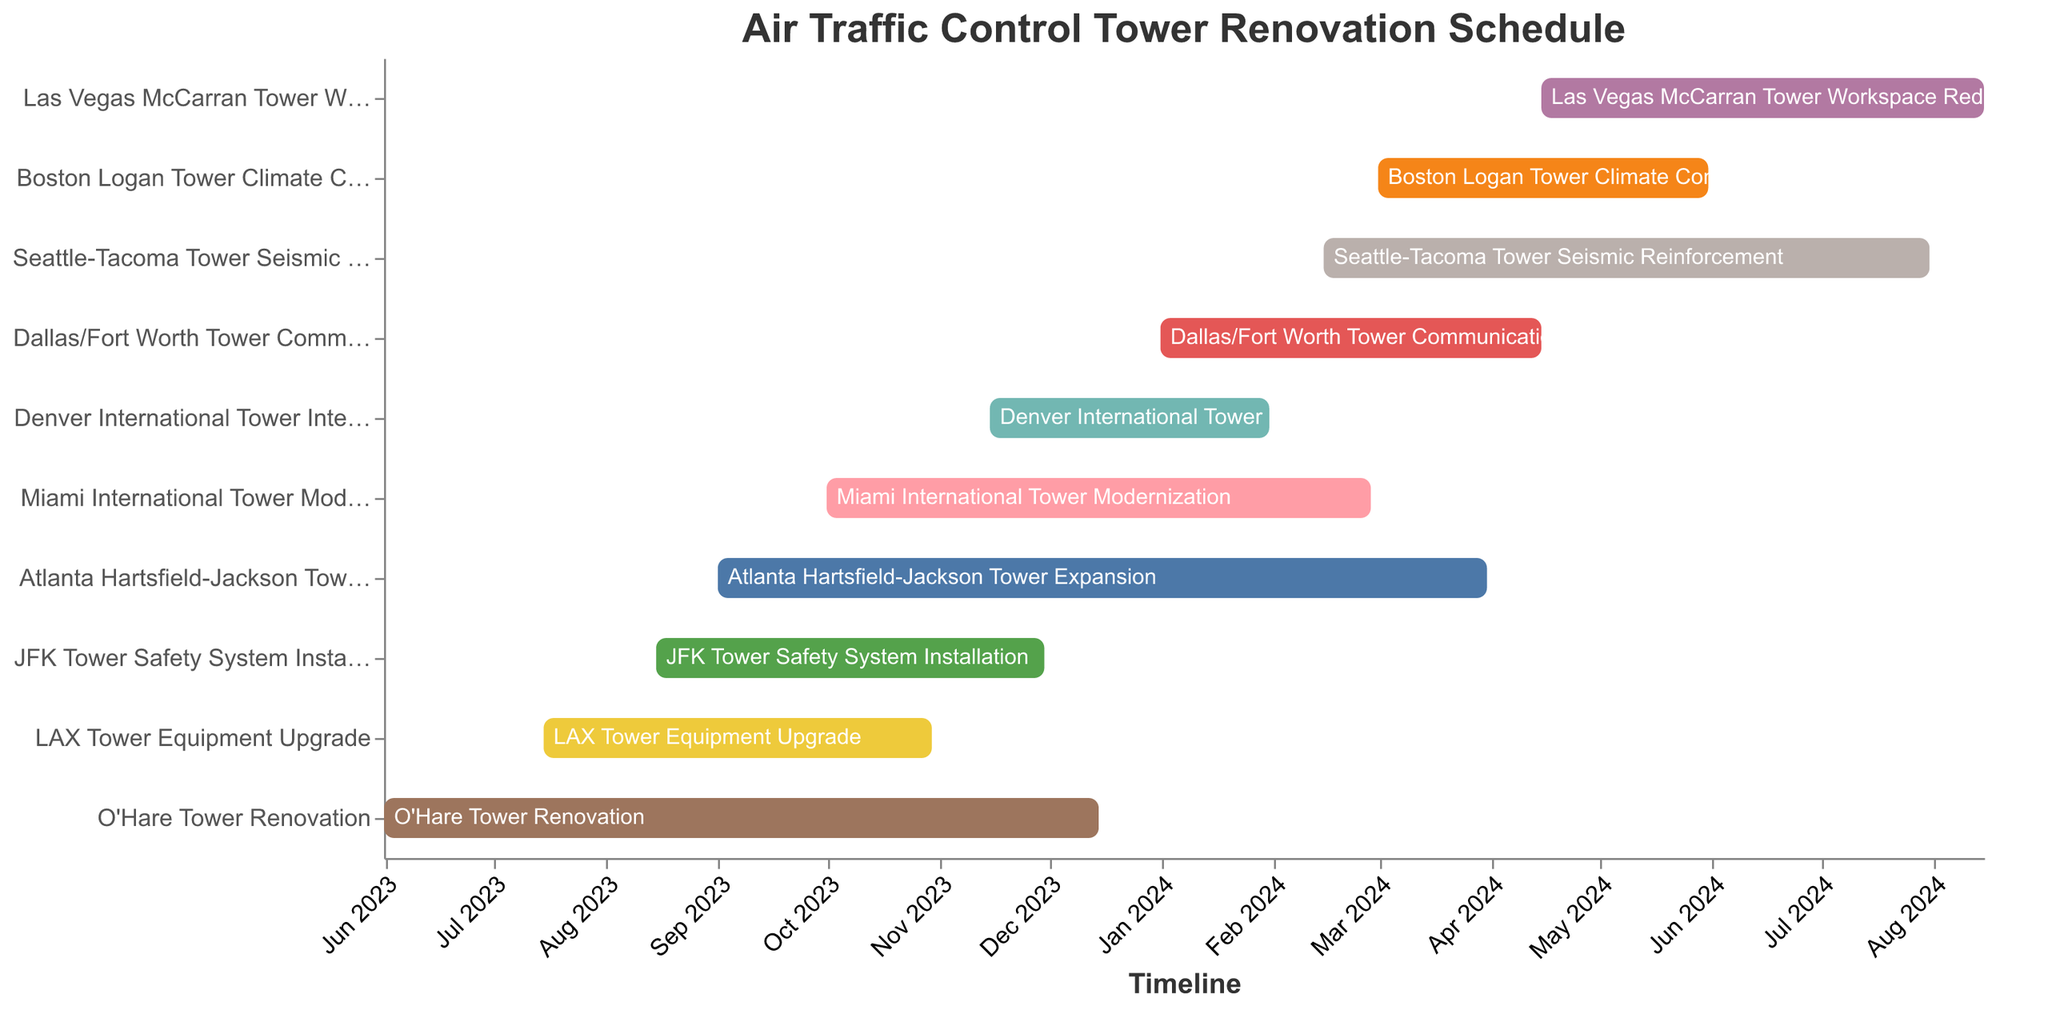What's the title of the chart? The title of the chart is displayed at the top and prominently marked. The text is "Air Traffic Control Tower Renovation Schedule".
Answer: Air Traffic Control Tower Renovation Schedule Which renovation project has the longest duration? By comparing the duration for each renovation project, the Atlanta Hartsfield-Jackson Tower Expansion has the longest duration of 213 days.
Answer: Atlanta Hartsfield-Jackson Tower Expansion Which project starts first and which one ends last? The timeline shows that the O'Hare Tower Renovation starts first on 2023-06-01, and the Seattle-Tacoma Tower Seismic Reinforcement ends last on 2024-07-31.
Answer: O'Hare Tower Renovation, Seattle-Tacoma Tower Seismic Reinforcement How many projects are scheduled to start before September 2023? The projects that start before September 2023 are O'Hare Tower Renovation and LAX Tower Equipment Upgrade. That's a total of 2 projects.
Answer: 2 Which projects overlap in the month of November 2023? By examining the Gantt chart, the projects that overlap in November 2023 are O'Hare Tower Renovation, LAX Tower Equipment Upgrade, JFK Tower Safety System Installation, and Miami International Tower Modernization.
Answer: O'Hare Tower Renovation, LAX Tower Equipment Upgrade, JFK Tower Safety System Installation, Miami International Tower Modernization Which project has the shortest duration, and what is that duration? By comparing the durations of all projects, the Denver International Tower Interior Remodel has the shortest duration of 78 days.
Answer: Denver International Tower Interior Remodel, 78 days During the month of December 2023, how many projects are ongoing, and which are they? The projects ongoing in December 2023 include O'Hare Tower Renovation, Atlanta Hartsfield-Jackson Tower Expansion, Miami International Tower Modernization, and Denver International Tower Interior Remodel. That accounts for 4 projects.
Answer: 4 How many projects are set to begin in 2024? By counting the start dates in 2024, the projects are Dallas/Fort Worth Tower Communications Upgrade, Seattle-Tacoma Tower Seismic Reinforcement, Boston Logan Tower Climate Control System, and Las Vegas McCarran Tower Workspace Redesign. That is a total of 4 projects.
Answer: 4 What’s the average duration of all the renovation projects? Sum up all the durations (198 + 108 + 213 + 107 + 151 + 78 + 105 + 168 + 92 + 123) to get 1343. Then, divide by the number of projects which is 10. The average duration is 134.3 days.
Answer: 134.3 days 